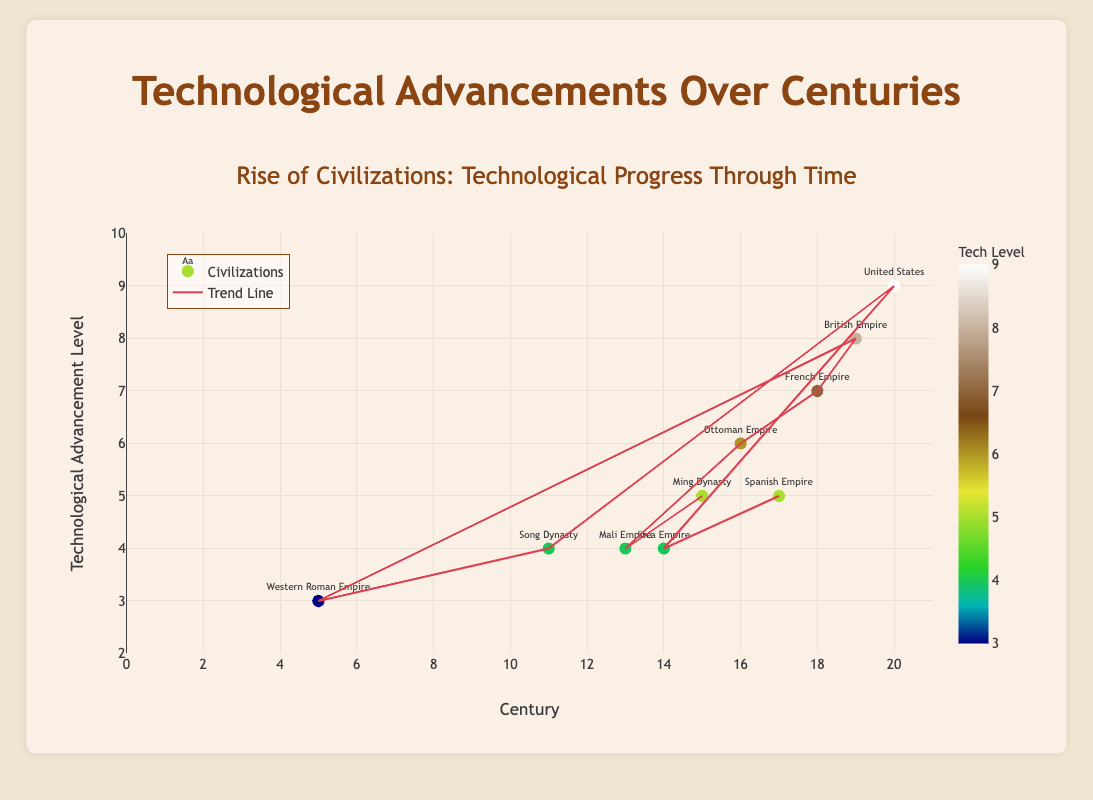How many civilizations are represented in the scatter plot? To determine the number of civilizations, count the unique civilization names in the figure's scatter plot.
Answer: 10 Which civilization reached the highest level of technological advancement, and in which century did it occur? Identify the data point with the highest y-value (technological advancement) and note its corresponding civilization and century along the x-axis.
Answer: United States, 20th century Which two centuries show the same level of technological advancement of 4, and which civilizations do they represent? Find the y-value of 4 on the scatter plot and identify the corresponding x-values (centuries) and their civilizations.
Answer: 13th century (Mali Empire) and 14th century (Inca Empire) Compare the technological advancements of the British Empire and the Spanish Empire. Which one had a higher value, and what are their respective values? Look at the y-values for the British Empire and the Spanish Empire and compare them.
Answer: British Empire (8), Spanish Empire (5) What is the trend in technological advancements from the 5th century to the 20th century as shown by the trend line? Observe the trend line from the left end of the x-axis (5th century) to the right end (20th century). Note if it generally slopes upwards, downwards, or remains flat.
Answer: Upward Which century saw the biggest jump in technological advancement compared to the previous century? Examine the differences in y-values between consecutive centuries and identify the largest jump.
Answer: 19th century compared to 18th century How many civilizations had a technological advancement level of 5? Count the data points with a y-value of 5 on the scatter plot.
Answer: 2 What is the average technological advancement level for the 11th, 13th, and 15th centuries? Identify the y-values for the 11th, 13th, and 15th centuries, sum them, and divide by the number of these centuries (3). Calculation: (4 + 4 + 5) / 3
Answer: 4.33 Is there any civilization from the 5th century that had a technological advancement level lower than the average advancement from the 14th century's civilizations? Compare the y-value of the Western Roman Empire (5th century) with the average of the y-values of the 14th century civilizations. The 14th century has only one civilization (Inca Empire) with a value of 4.
Answer: Yes, 3<4 Does the scatter plot suggest any civilization in the 17th century had a higher technological advancement than any in the 18th century? Compare the y-values of the data points for the 17th century and the 18th century.
Answer: No 